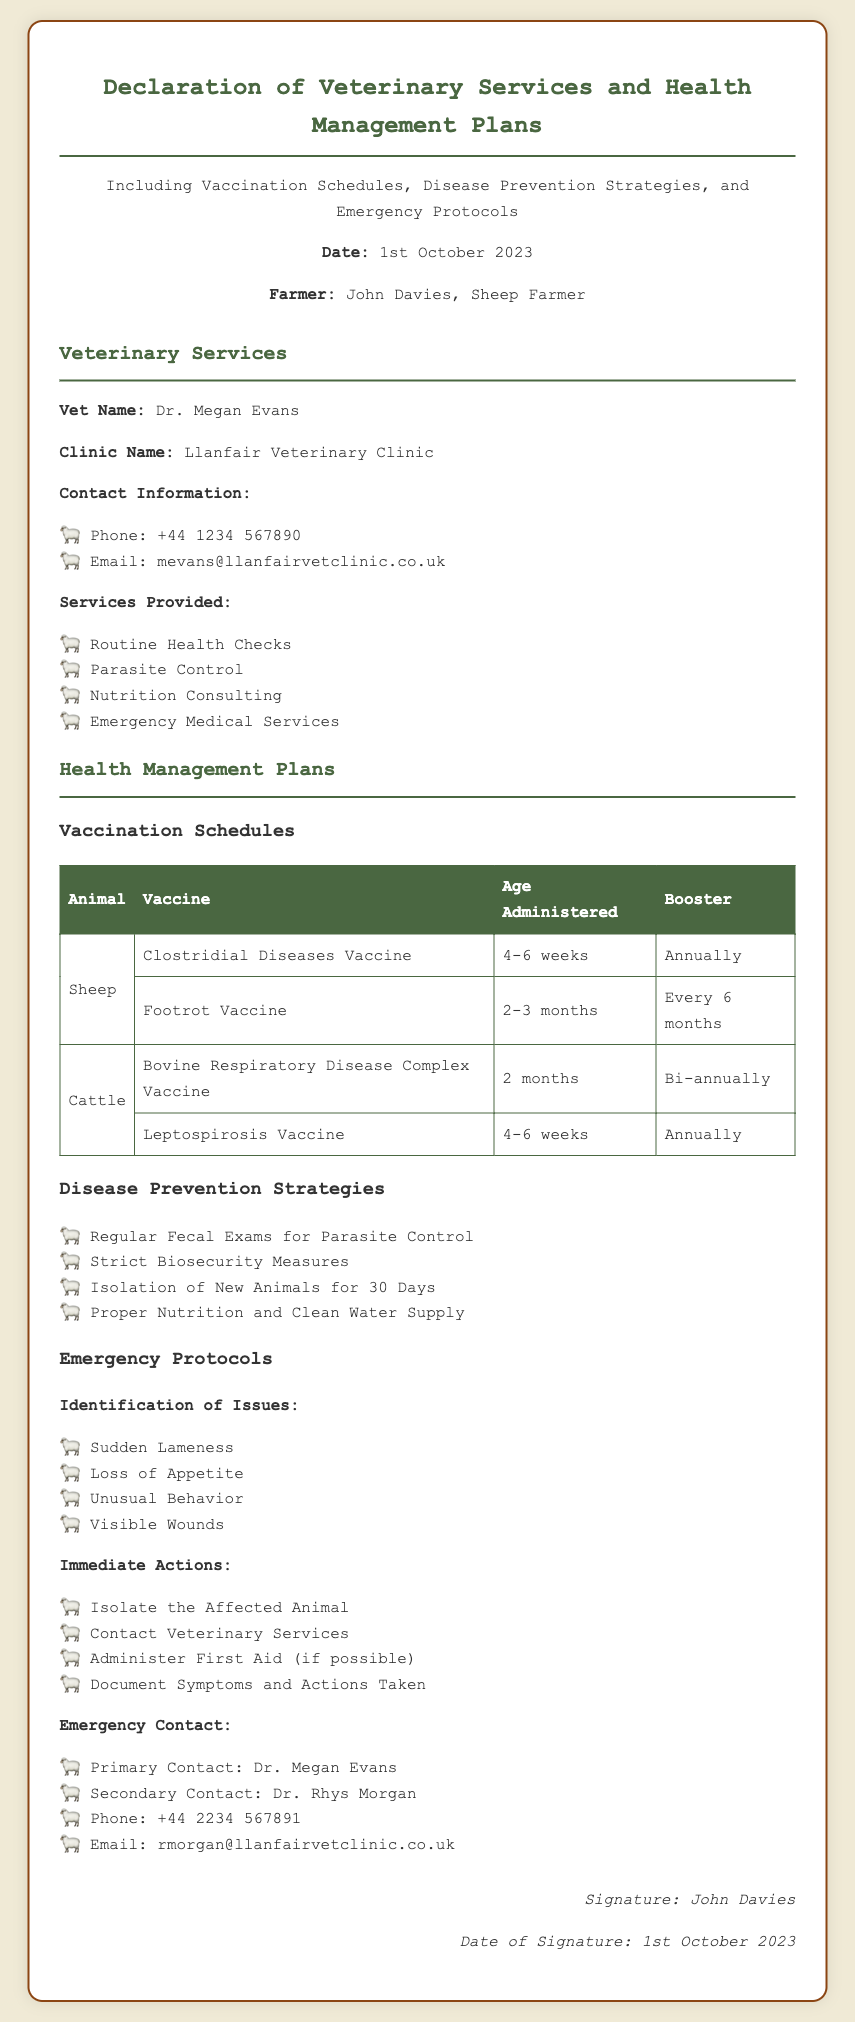What is the date of the declaration? The date is specifically mentioned in the document as 1st October 2023.
Answer: 1st October 2023 Who is the veterinarian? The veterinarian's name is listed in the document as Dr. Megan Evans.
Answer: Dr. Megan Evans What clinic does the veterinarian work at? The document specifies that the veterinarian works at Llanfair Veterinary Clinic.
Answer: Llanfair Veterinary Clinic How often should the Clostridial Diseases Vaccine be boosted? The document states that the booster for the Clostridial Diseases Vaccine is to be administered annually.
Answer: Annually What is the primary identification issue in emergencies? Among the identified issues, "Sudden Lameness" is listed as the first on the list in the document.
Answer: Sudden Lameness What immediate action should be taken for an affected animal? One of the immediate actions listed is to "Isolate the Affected Animal."
Answer: Isolate the Affected Animal What type of disease prevention strategies are mentioned? The document lists "Regular Fecal Exams for Parasite Control" as one of the disease prevention strategies.
Answer: Regular Fecal Exams for Parasite Control What is the contact number for Dr. Rhys Morgan? The document provides the contact number as +44 2234 567891.
Answer: +44 2234 567891 What type of services are provided by the veterinary clinic? The document lists several services including "Routine Health Checks" as one of the services provided.
Answer: Routine Health Checks 